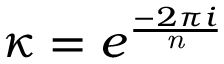<formula> <loc_0><loc_0><loc_500><loc_500>\kappa = e ^ { \frac { - 2 \pi i } { n } }</formula> 